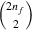Convert formula to latex. <formula><loc_0><loc_0><loc_500><loc_500>\binom { 2 n _ { f } } { 2 }</formula> 